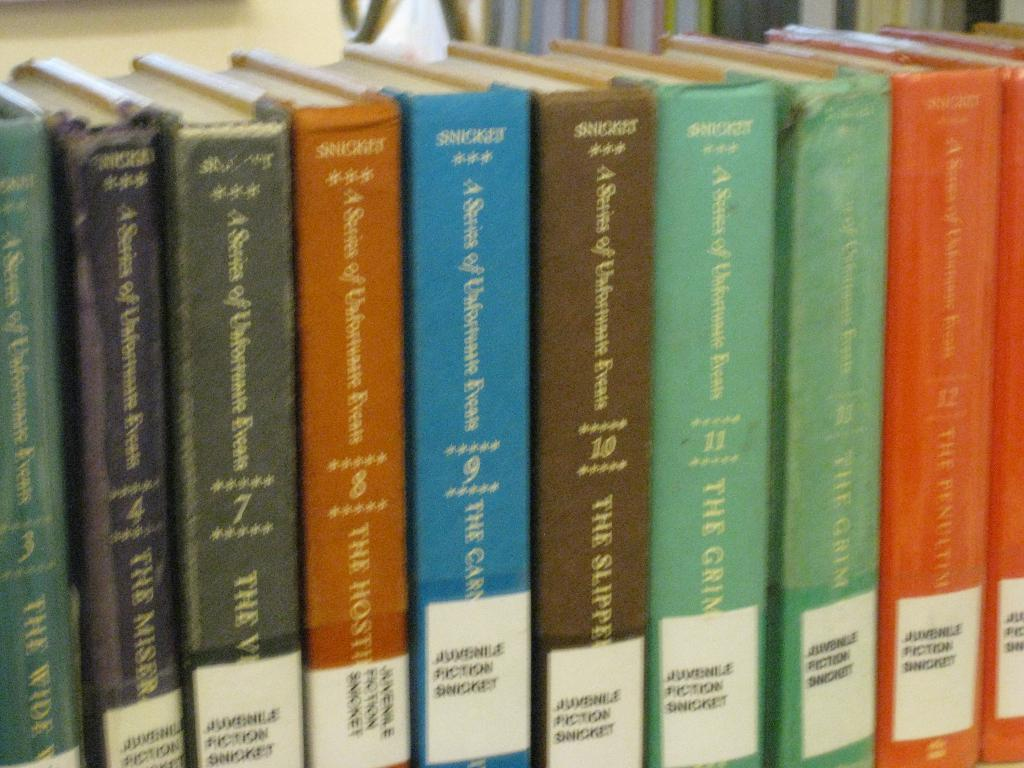<image>
Share a concise interpretation of the image provided. a book that has the name Snicket at the top 